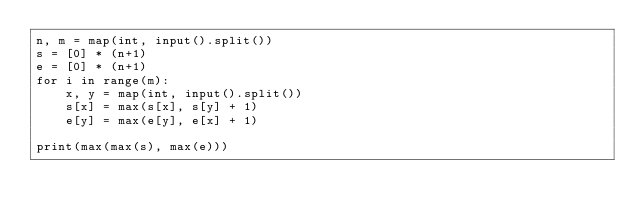<code> <loc_0><loc_0><loc_500><loc_500><_Python_>n, m = map(int, input().split())
s = [0] * (n+1)
e = [0] * (n+1)
for i in range(m):
    x, y = map(int, input().split())
    s[x] = max(s[x], s[y] + 1)
    e[y] = max(e[y], e[x] + 1)

print(max(max(s), max(e)))</code> 